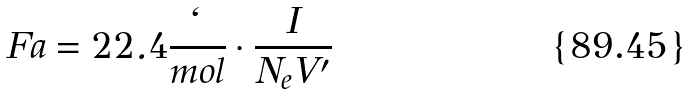Convert formula to latex. <formula><loc_0><loc_0><loc_500><loc_500>F a = 2 2 . 4 \frac { \ell } { m o l } \cdot \frac { I } { N _ { e } V ^ { \prime } }</formula> 